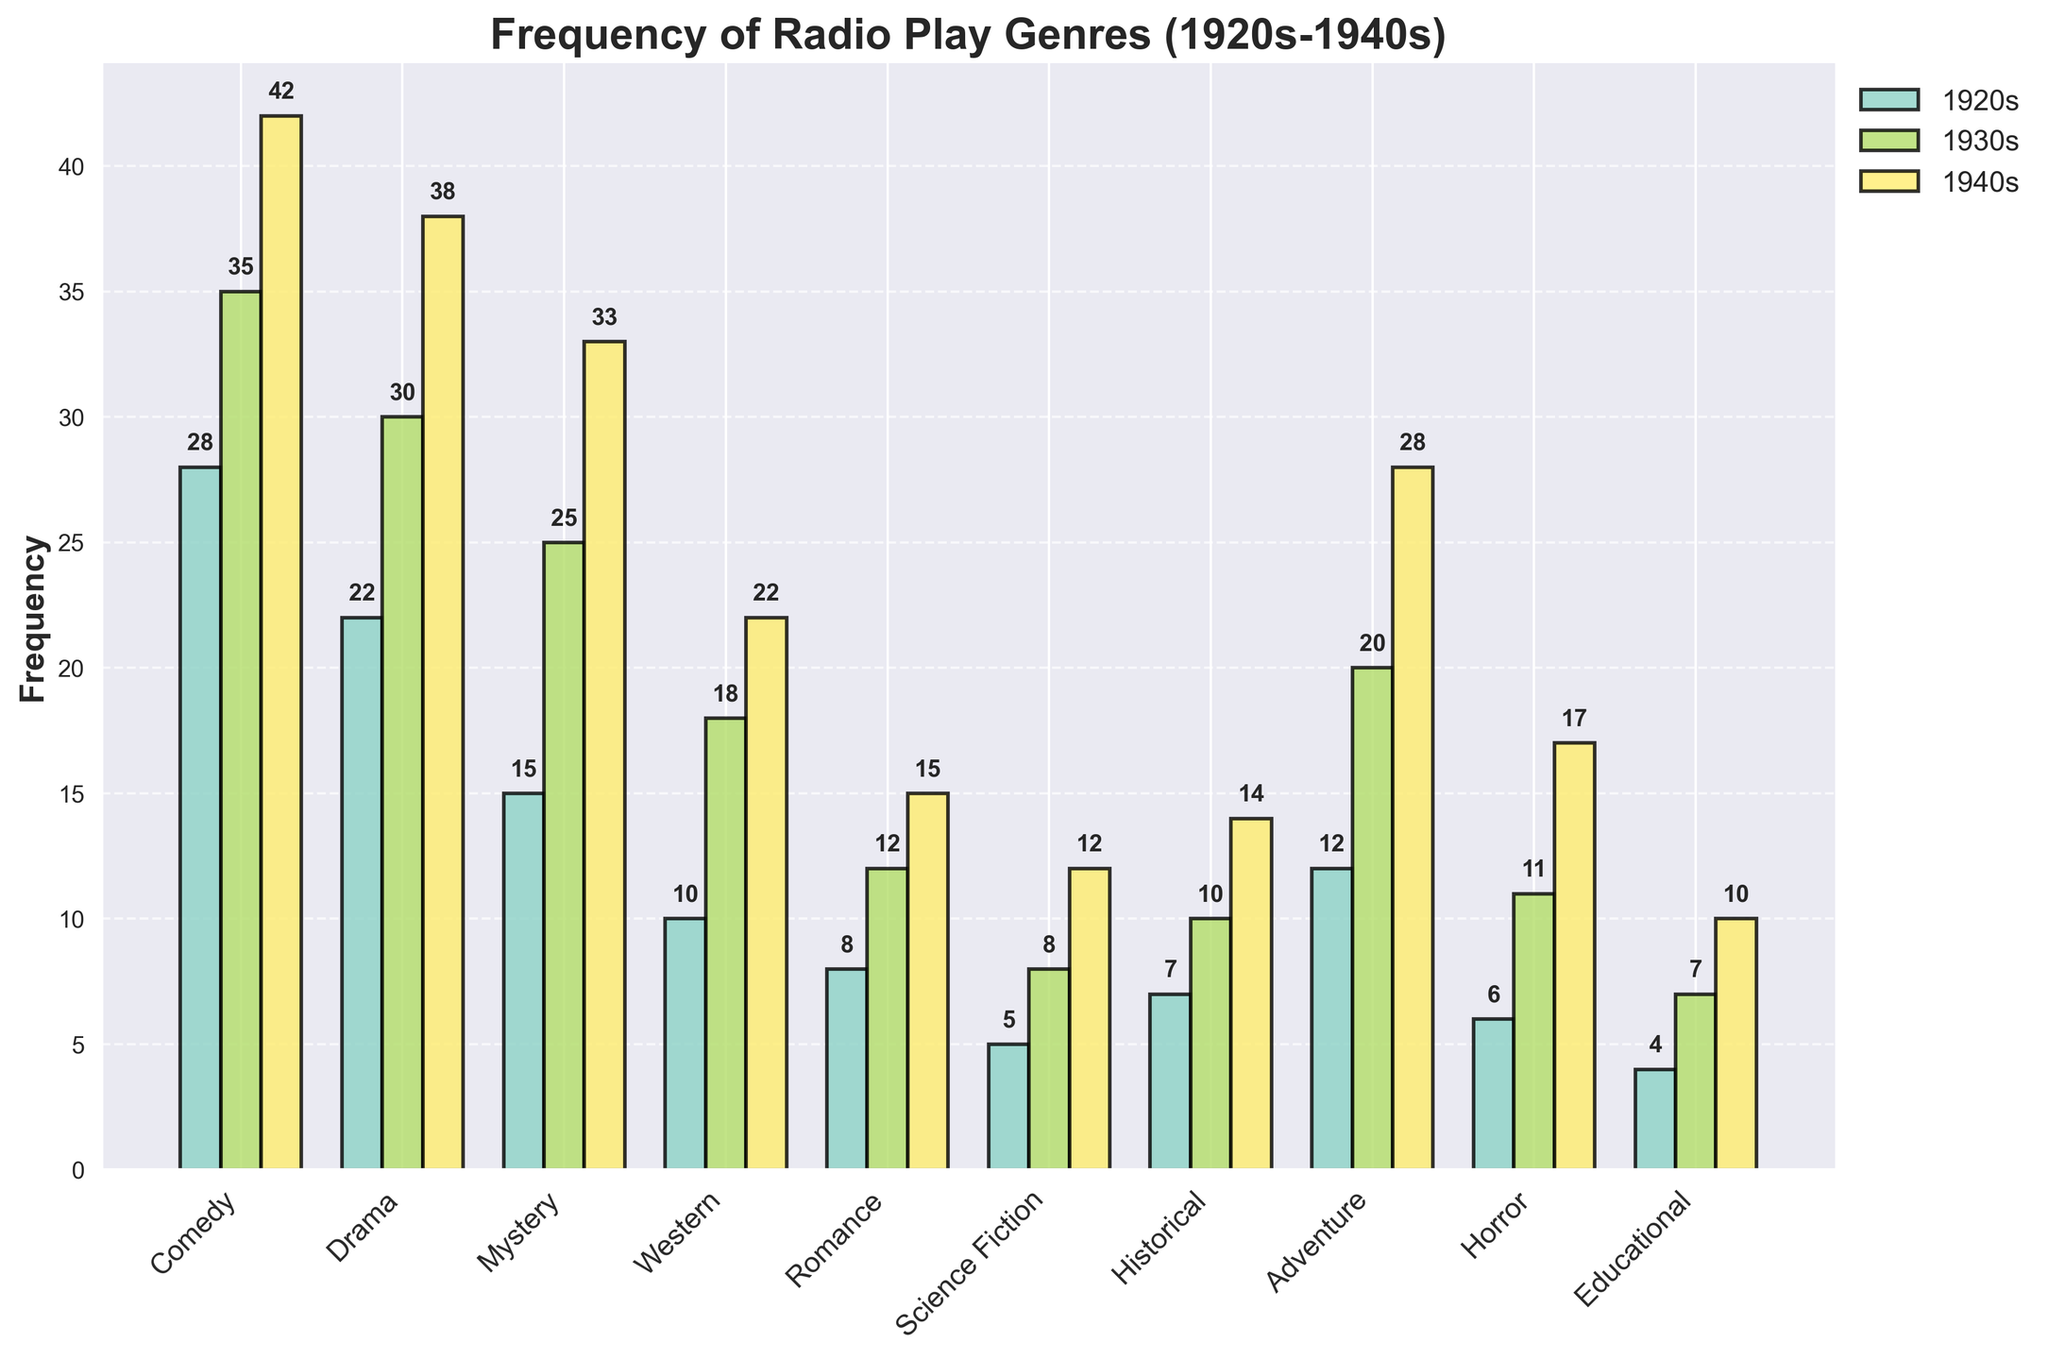Which genre had the highest frequency in the 1930s? By looking at the height of the bars for the 1930s category, the Comedy genre has the highest bar, representing a frequency of 35.
Answer: Comedy Which genre saw the most significant increase in frequency from the 1920s to the 1940s? By comparing the heights of the bars for each genre in the 1920s and the 1940s, Mystery had a significant increase, growing from 15 in the 1920s to 33 in the 1940s, a difference of 18.
Answer: Mystery What is the average frequency of the Drama genre across the three decades? The frequencies for Drama are 22 (1920s), 30 (1930s), and 38 (1940s). Adding them gives 90, and the average is 90/3, which is 30.
Answer: 30 How much higher is the frequency of the Horror genre in the 1940s compared to the 1920s? Horror has a frequency of 6 in the 1920s and 17 in the 1940s. The difference is 17 - 6, which is 11.
Answer: 11 Which genre had the closest frequency values in the 1930s and 1940s? By examining the bars for the 1930s and 1940s, the Western genre had values 18 (1930s) and 22 (1940s), with the smallest difference of 4.
Answer: Western What is the total frequency for the Adventure genre across all three decades? The frequencies for Adventure are 12 (1920s), 20 (1930s), and 28 (1940s). Summing these up gives 12 + 20 + 28 = 60.
Answer: 60 Compare the frequency of the Romance genre in the 1920s and the Science Fiction genre in the 1940s. Which one is higher? The Romance genre in the 1920s has a frequency of 8, while Science Fiction in the 1940s has a frequency of 12. Since 12 is greater than 8, Science Fiction is higher.
Answer: Science Fiction What is the total frequency of all genres combined in the 1920s? Adding the frequencies of all genres in the 1920s: 28 (Comedy), 22 (Drama), 15 (Mystery), 10 (Western), 8 (Romance), 5 (Science Fiction), 7 (Historical), 12 (Adventure), 6 (Horror), 4 (Educational), the total is 117.
Answer: 117 Which genre has the smallest increase in frequency from the 1920s to the 1940s? By comparing the increases for each genre across the decades, Educational increases from 4 (1920s) to 10 (1940s), which is an increase of 6. This is the smallest increase among all genres.
Answer: Educational What is the combined frequency of the Comedy and Drama genres in the 1940s? The frequencies for Comedy and Drama in the 1940s are 42 and 38 respectively. Adding them together gives 42 + 38 = 80.
Answer: 80 